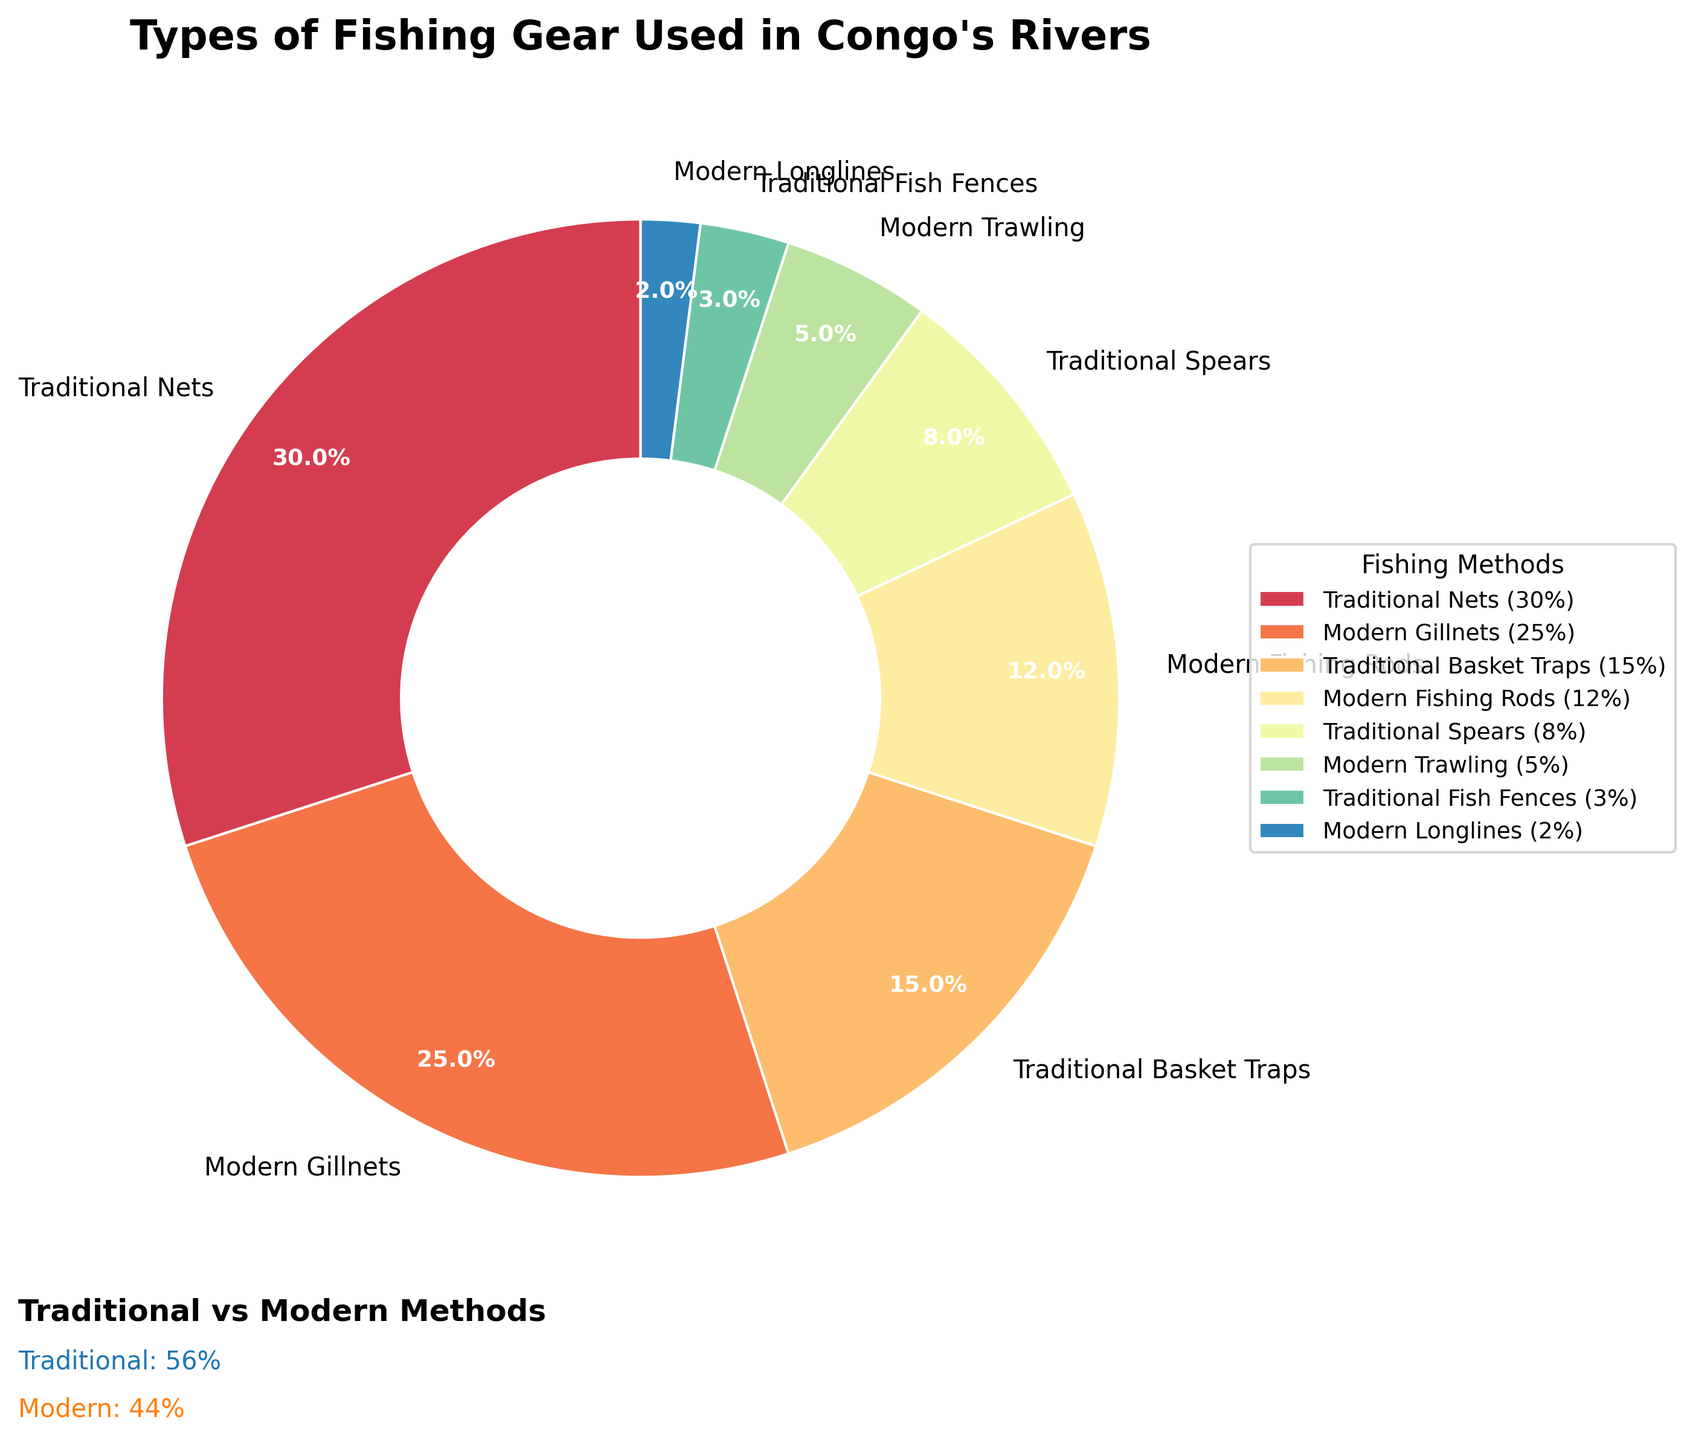Which traditional method has the highest percentage? To determine the traditional method with the highest percentage, look for the method labeled under "Traditional" with the largest section of the pie chart. "Traditional Nets" has the highest percentage among traditional methods.
Answer: Traditional Nets What is the combined percentage of all modern fishing methods? Add the percentages of each modern fishing method. The modern methods are "Modern Gillnets" (25%), "Modern Fishing Rods" (12%), "Modern Trawling" (5%), and "Modern Longlines" (2%). Summing these gives 25% + 12% + 5% + 2% = 44%.
Answer: 44% Which method, traditional fish fences or modern longlines, has a lower percentage? Compare the percentages of "Traditional Fish Fences" and "Modern Longlines". Traditional Fish Fences have 3% and Modern Longlines have 2%. Since 2% is less than 3%, Modern Longlines has a lower percentage.
Answer: Modern Longlines How much larger is the percentage of traditional spears compared to modern trawling? Subtract the percentage of Modern Trawling (5%) from Traditional Spears (8%). The difference is 8% - 5% = 3%.
Answer: 3% If you combine traditional basket traps and modern fishing rods, what is their total percentage? Add the percentages of Traditional Basket Traps (15%) and Modern Fishing Rods (12%). The total is 15% + 12% = 27%.
Answer: 27% Which category has the most types of fishing methods? Count the number of fishing methods in each category from the legend. There are five traditional methods and four modern methods. Five is greater than four, so traditional methods have more types.
Answer: Traditional What is the ratio of the percentage of traditional nets to modern gillnets? Divide the percentage of Traditional Nets (30%) by Modern Gillnets (25%). The ratio is 30/25 = 1.2.
Answer: 1.2 What percentage of the fishing methods belong to traditional methods? Add the percentages of all traditional methods: "Traditional Nets" (30%), "Traditional Basket Traps" (15%), "Traditional Spears" (8%), and "Traditional Fish Fences" (3%). Summing these gives 30% + 15% + 8% + 3% = 56%.
Answer: 56% Which fishing method occupies the smallest section of the pie chart? Observe the smallest section of the pie chart. "Modern Longlines" with 2% is the smallest.
Answer: Modern Longlines 